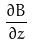Convert formula to latex. <formula><loc_0><loc_0><loc_500><loc_500>\frac { \partial B } { \partial z }</formula> 